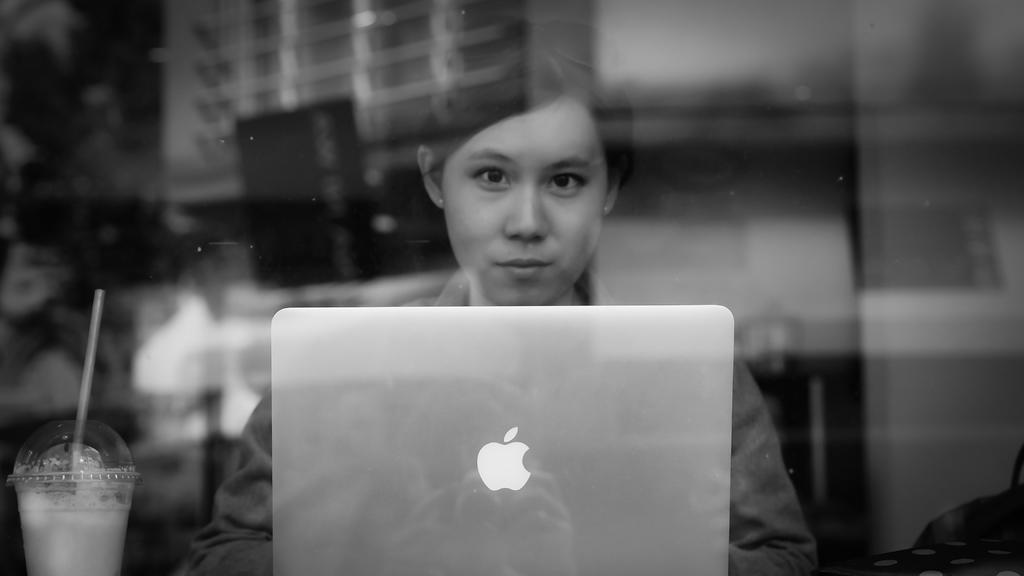Who is the main subject in the image? There is a woman in the image. Where is the woman located in the image? The woman is in the middle of the image. What is in front of the woman in the image? There is a laptop and a cup with a drink in it in front of the woman. What is the color scheme of the image? The image is in black and white. What type of coat is the woman wearing in the image? There is no coat visible in the image, as it is in black and white and does not show any clothing details. What news story is the woman reading on the laptop in the image? There is no information about the content on the laptop in the image, so it cannot be determined what news story the woman might be reading. 